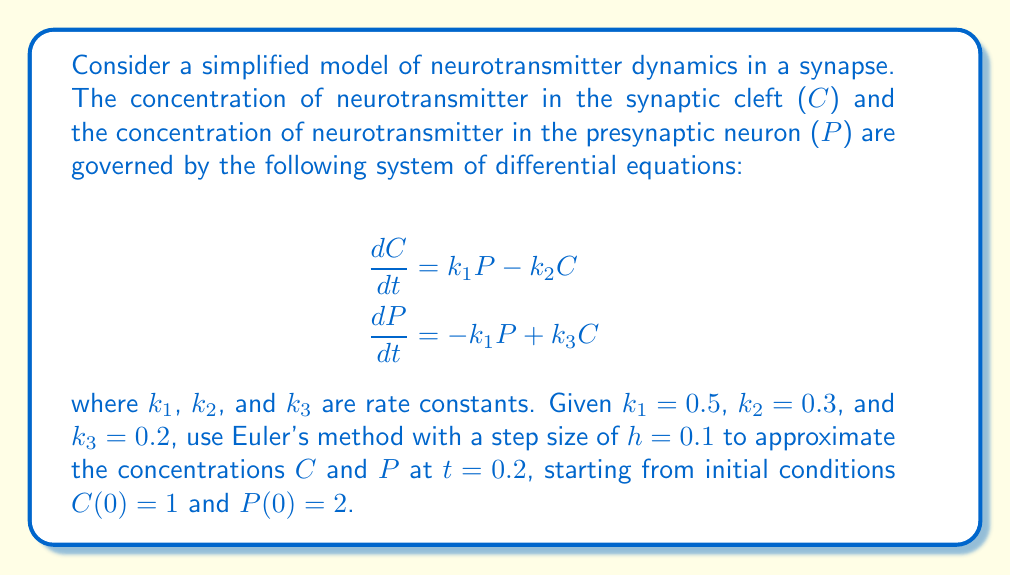Can you solve this math problem? To solve this system using Euler's method, we follow these steps:

1) Euler's method for a system of ODEs is given by:
   $$y_{n+1} = y_n + hf(t_n, y_n)$$
   where $y$ is a vector of the dependent variables.

2) In our case, we have:
   $$\begin{bmatrix} C_{n+1} \\ P_{n+1} \end{bmatrix} = \begin{bmatrix} C_n \\ P_n \end{bmatrix} + h\begin{bmatrix} k_1P_n - k_2C_n \\ -k_1P_n + k_3C_n \end{bmatrix}$$

3) Given: $k_1 = 0.5$, $k_2 = 0.3$, $k_3 = 0.2$, $h = 0.1$, $C(0) = 1$, $P(0) = 2$

4) We need to perform 2 iterations to reach $t = 0.2$:

   Iteration 1 ($t = 0.1$):
   $$C_1 = 1 + 0.1(0.5 \cdot 2 - 0.3 \cdot 1) = 1.07$$
   $$P_1 = 2 + 0.1(-0.5 \cdot 2 + 0.2 \cdot 1) = 1.9$$

   Iteration 2 ($t = 0.2$):
   $$C_2 = 1.07 + 0.1(0.5 \cdot 1.9 - 0.3 \cdot 1.07) = 1.1289$$
   $$P_2 = 1.9 + 0.1(-0.5 \cdot 1.9 + 0.2 \cdot 1.07) = 1.8114$$

5) Therefore, at $t = 0.2$:
   $C \approx 1.1289$
   $P \approx 1.8114$
Answer: $C(0.2) \approx 1.1289$, $P(0.2) \approx 1.8114$ 